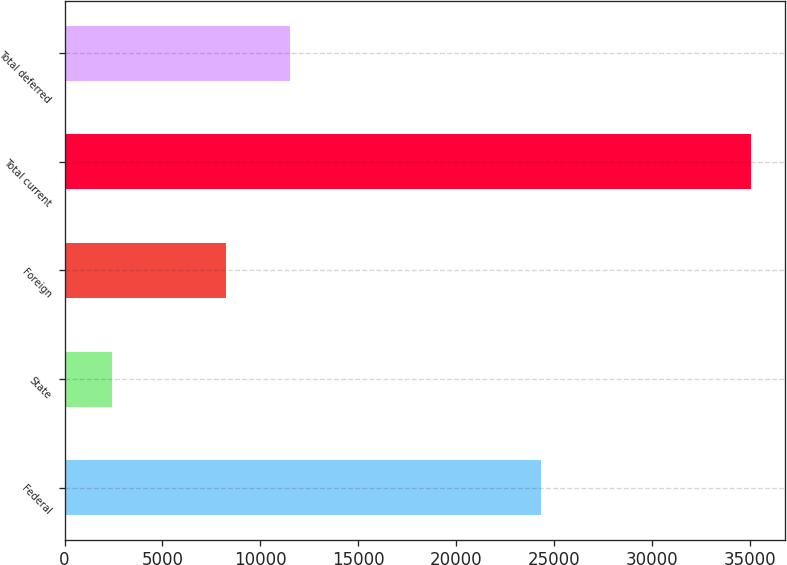<chart> <loc_0><loc_0><loc_500><loc_500><bar_chart><fcel>Federal<fcel>State<fcel>Foreign<fcel>Total current<fcel>Total deferred<nl><fcel>24334<fcel>2437<fcel>8267<fcel>35038<fcel>11527.1<nl></chart> 